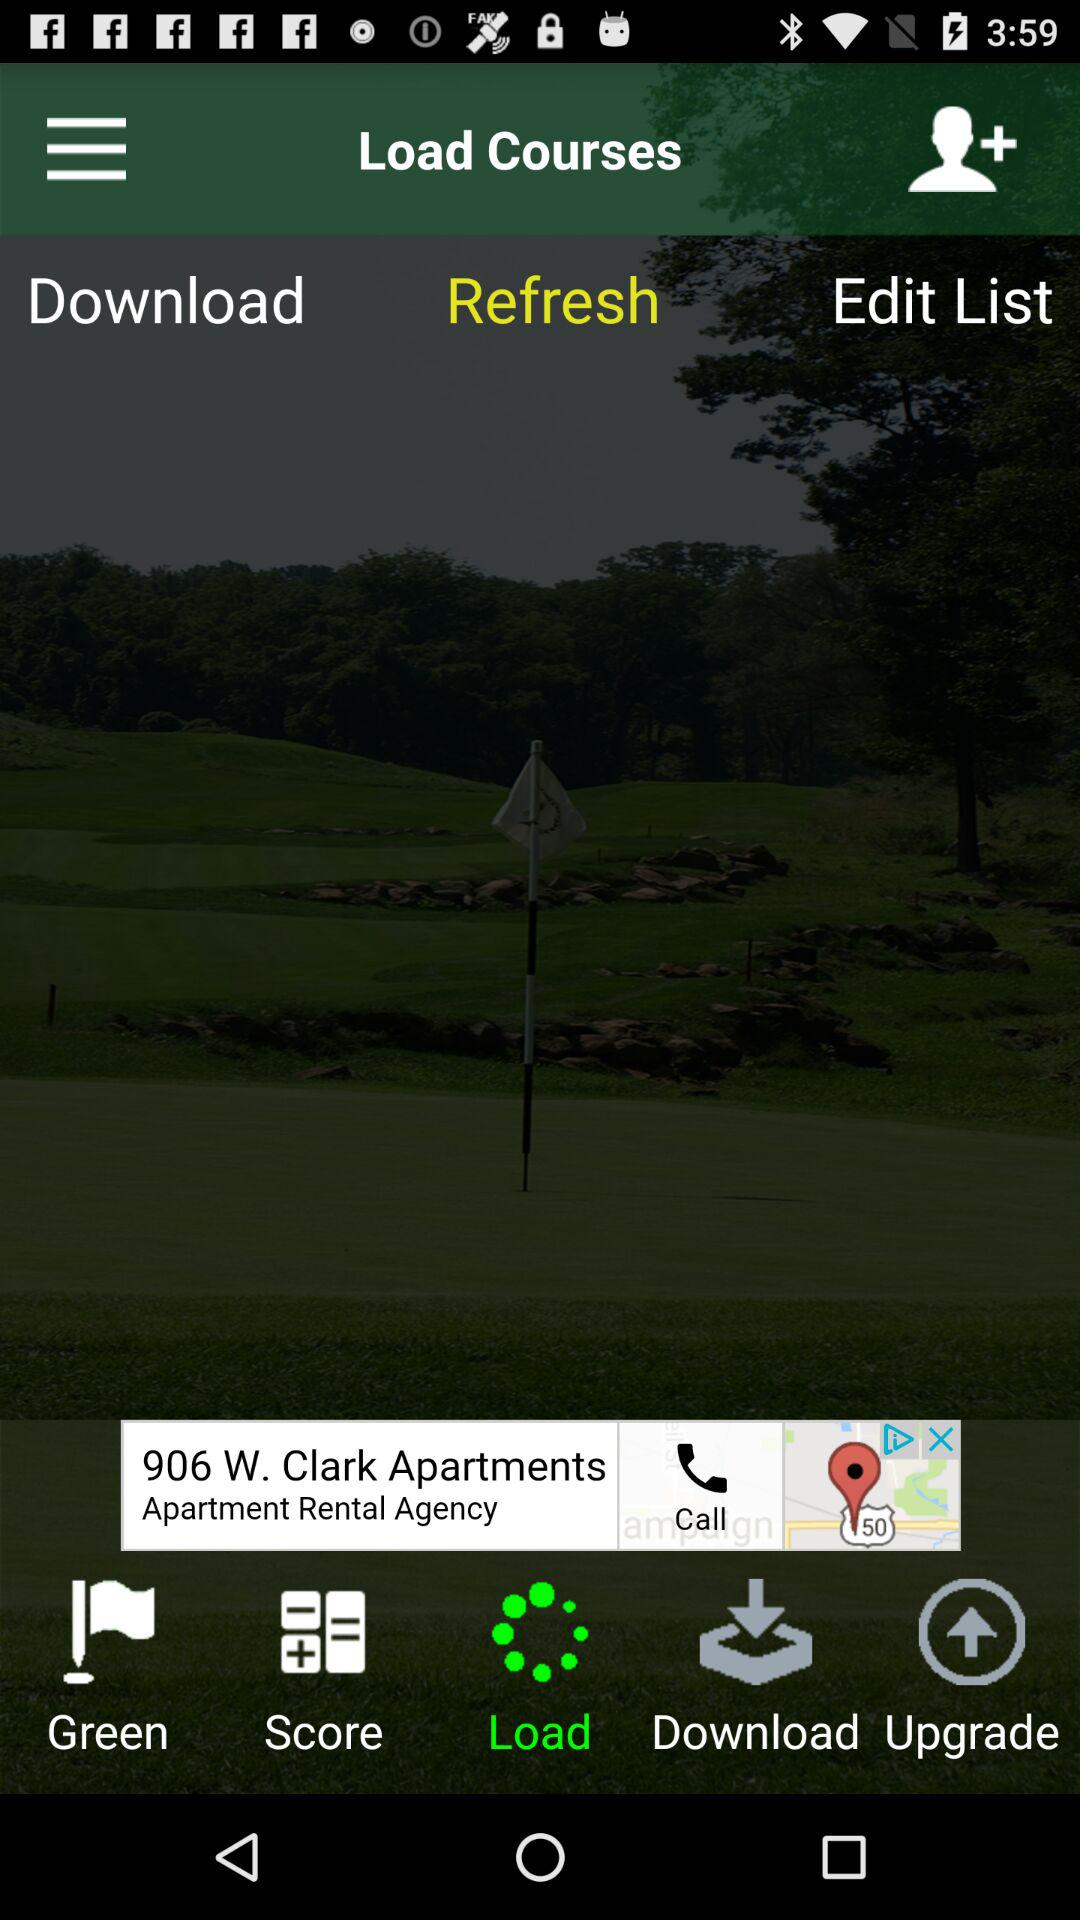Which tab is selected? The selected tabs are "Refresh" and "Load". 